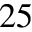Convert formula to latex. <formula><loc_0><loc_0><loc_500><loc_500>^ { 2 5 }</formula> 